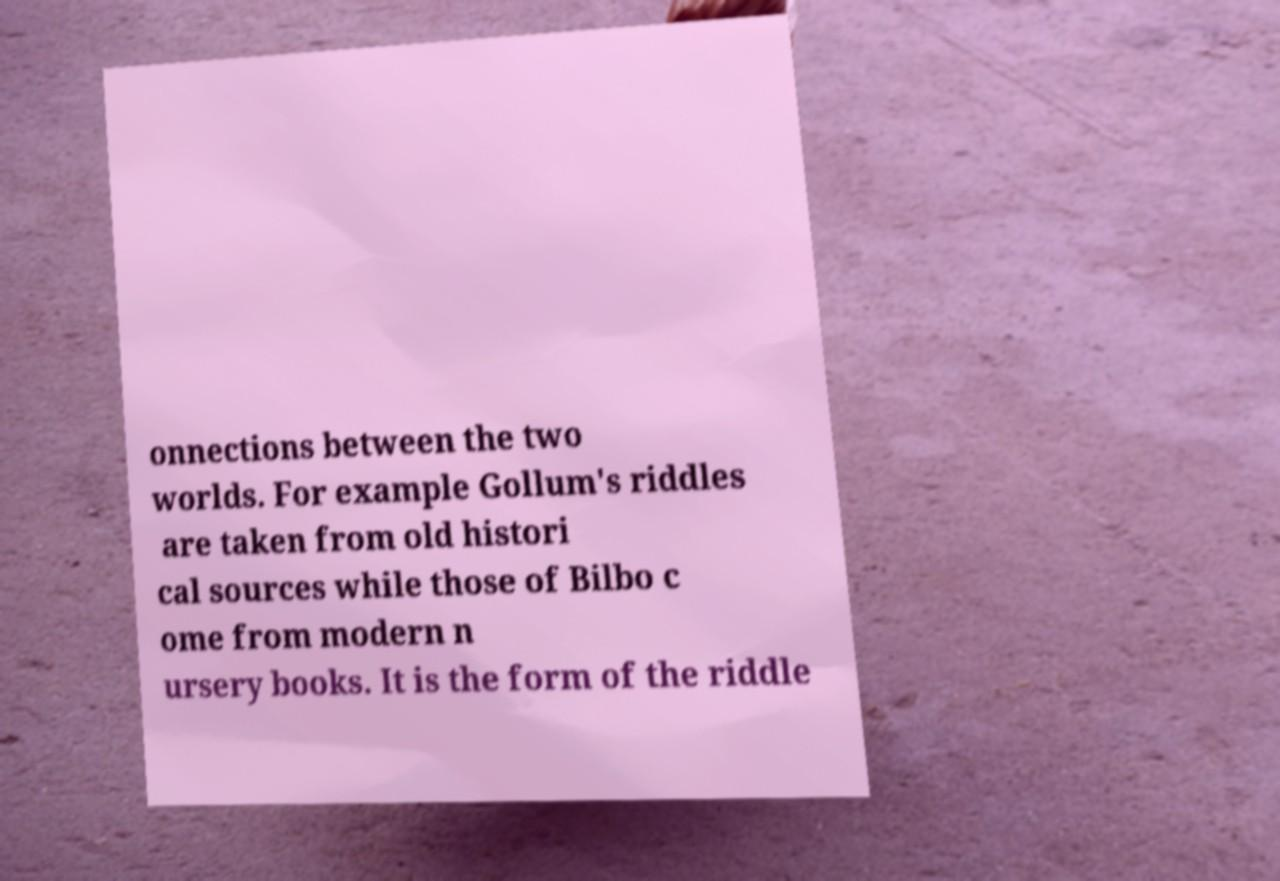There's text embedded in this image that I need extracted. Can you transcribe it verbatim? onnections between the two worlds. For example Gollum's riddles are taken from old histori cal sources while those of Bilbo c ome from modern n ursery books. It is the form of the riddle 